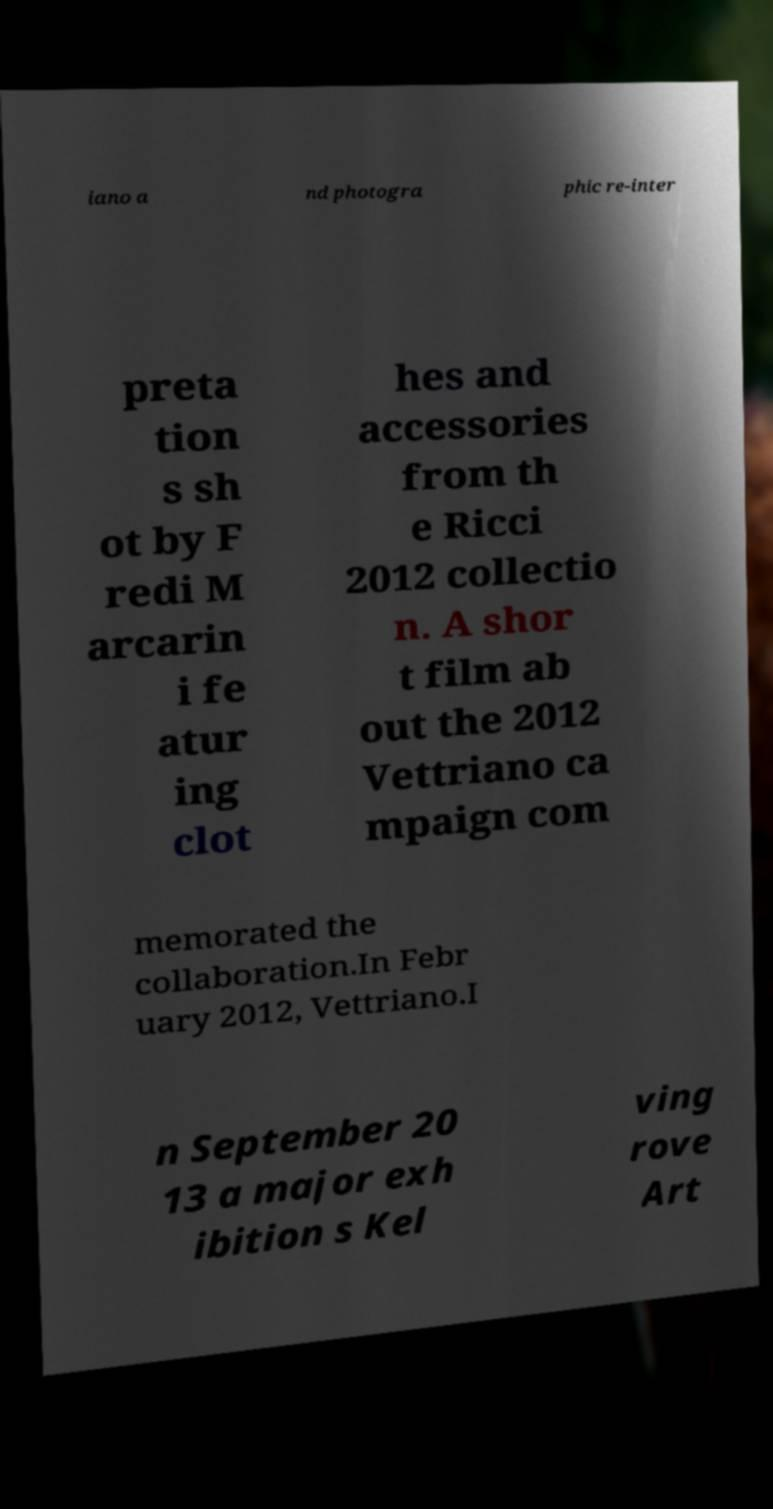Please identify and transcribe the text found in this image. iano a nd photogra phic re-inter preta tion s sh ot by F redi M arcarin i fe atur ing clot hes and accessories from th e Ricci 2012 collectio n. A shor t film ab out the 2012 Vettriano ca mpaign com memorated the collaboration.In Febr uary 2012, Vettriano.I n September 20 13 a major exh ibition s Kel ving rove Art 